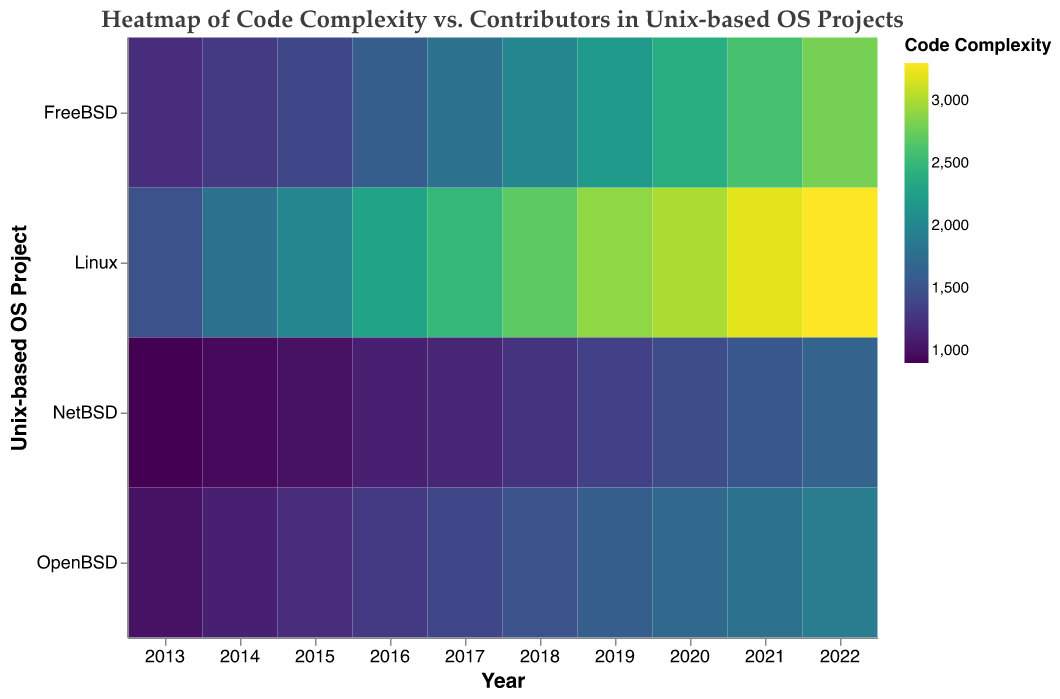Which OS project had the highest code complexity in 2022? To determine this, look at the color intensity for the year 2022 on the heatmap. The darkest color representing the highest code complexity corresponds to the "Linux" project.
Answer: Linux What was the trend in code complexity for the Linux project over the decade shown? Observe the color gradient for the Linux project from 2013 to 2022. The color transitions from lighter to darker shades, indicating increasing code complexity over the years.
Answer: Increasing How many contributors did the FreeBSD project have in 2019? Hover over or refer to the tooltip for the year 2019 along the FreeBSD row. The tooltip shows "Contributors: 20".
Answer: 20 Compare the code complexity between NetBSD and OpenBSD in 2015. Which one is higher? Look at the colors for both NetBSD and OpenBSD in 2015. OpenBSD has a slightly darker color indicating higher complexity compared to NetBSD.
Answer: OpenBSD What range of code complexity values is seen across all OS projects in 2020? Refer to the colors for all OS projects in 2020 and the color legend. Code complexity values range from around 1700 to 3000.
Answer: 1700 to 3000 Which project has the most consistent increase in contributors year over year? Examine the contributors' tooltip data across different years for each project. Linux shows the most consistent annual increase without any decrease.
Answer: Linux In which year did the FreeBSD project surpass 2000 in code complexity? Hover over the color for FreeBSD starting from 2018 and move forward until reaching more than 2000 in the tooltip. This happens in 2018.
Answer: 2018 How does the code complexity of NetBSD compare between the years 2016 and 2020? Check the color shading for the NetBSD project in 2016 and 2020. The color becomes darker from 2016 to 2020, indicating an increase in complexity.
Answer: Increased Can you identify a year where the OpenBSD project had fewer than 10 contributors? Hover over the color blocks for OpenBSD for each year and check the tooltip for the number of contributors. In 2013 and 2014, OpenBSD had fewer than 10 contributors.
Answer: 2013, 2014 What general pattern can you observe about the relationship between contributors and code complexity across these Unix-based OS projects? Generally, as the number of contributors increases within each project, the code complexity also tends to increase. This pattern can be inferred by observing the changing colors corresponding to rising contributor counts.
Answer: Increasing contributors tend to increase complexity 